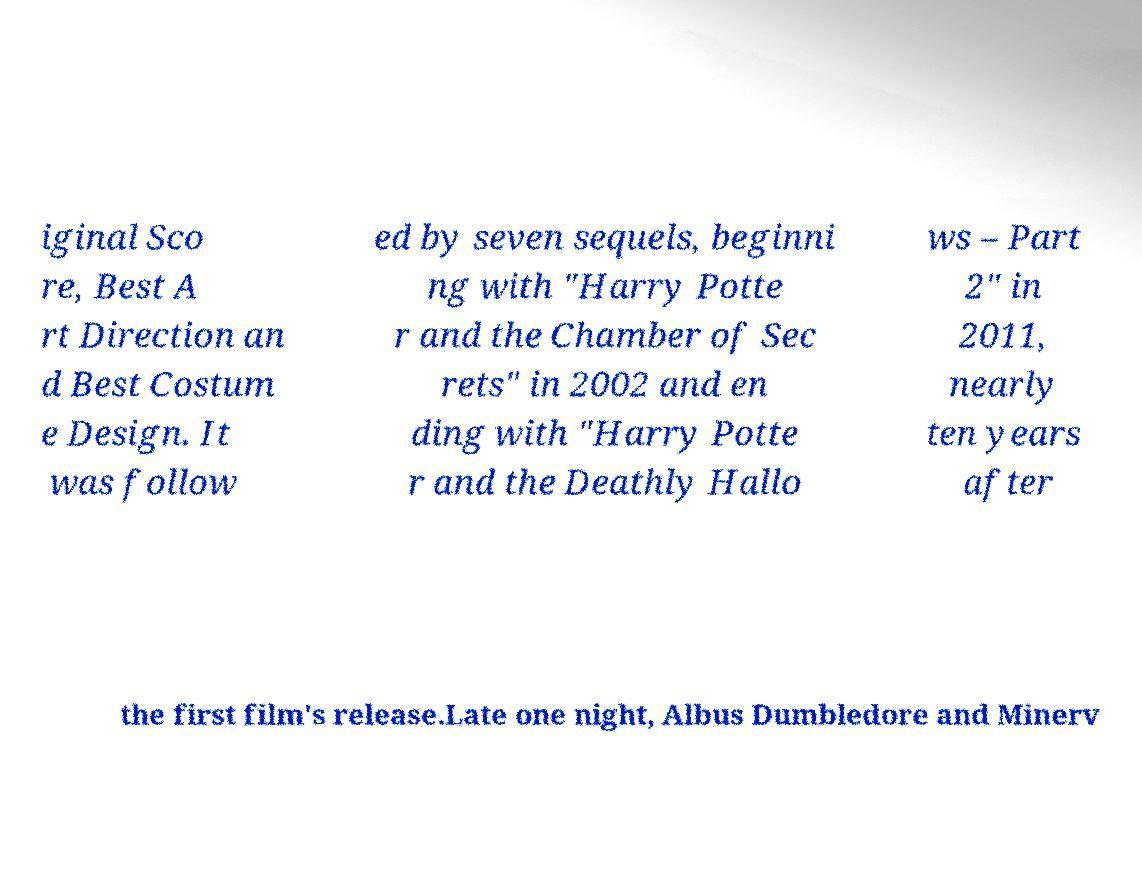Could you assist in decoding the text presented in this image and type it out clearly? iginal Sco re, Best A rt Direction an d Best Costum e Design. It was follow ed by seven sequels, beginni ng with "Harry Potte r and the Chamber of Sec rets" in 2002 and en ding with "Harry Potte r and the Deathly Hallo ws – Part 2" in 2011, nearly ten years after the first film's release.Late one night, Albus Dumbledore and Minerv 